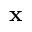Convert formula to latex. <formula><loc_0><loc_0><loc_500><loc_500>{ x }</formula> 